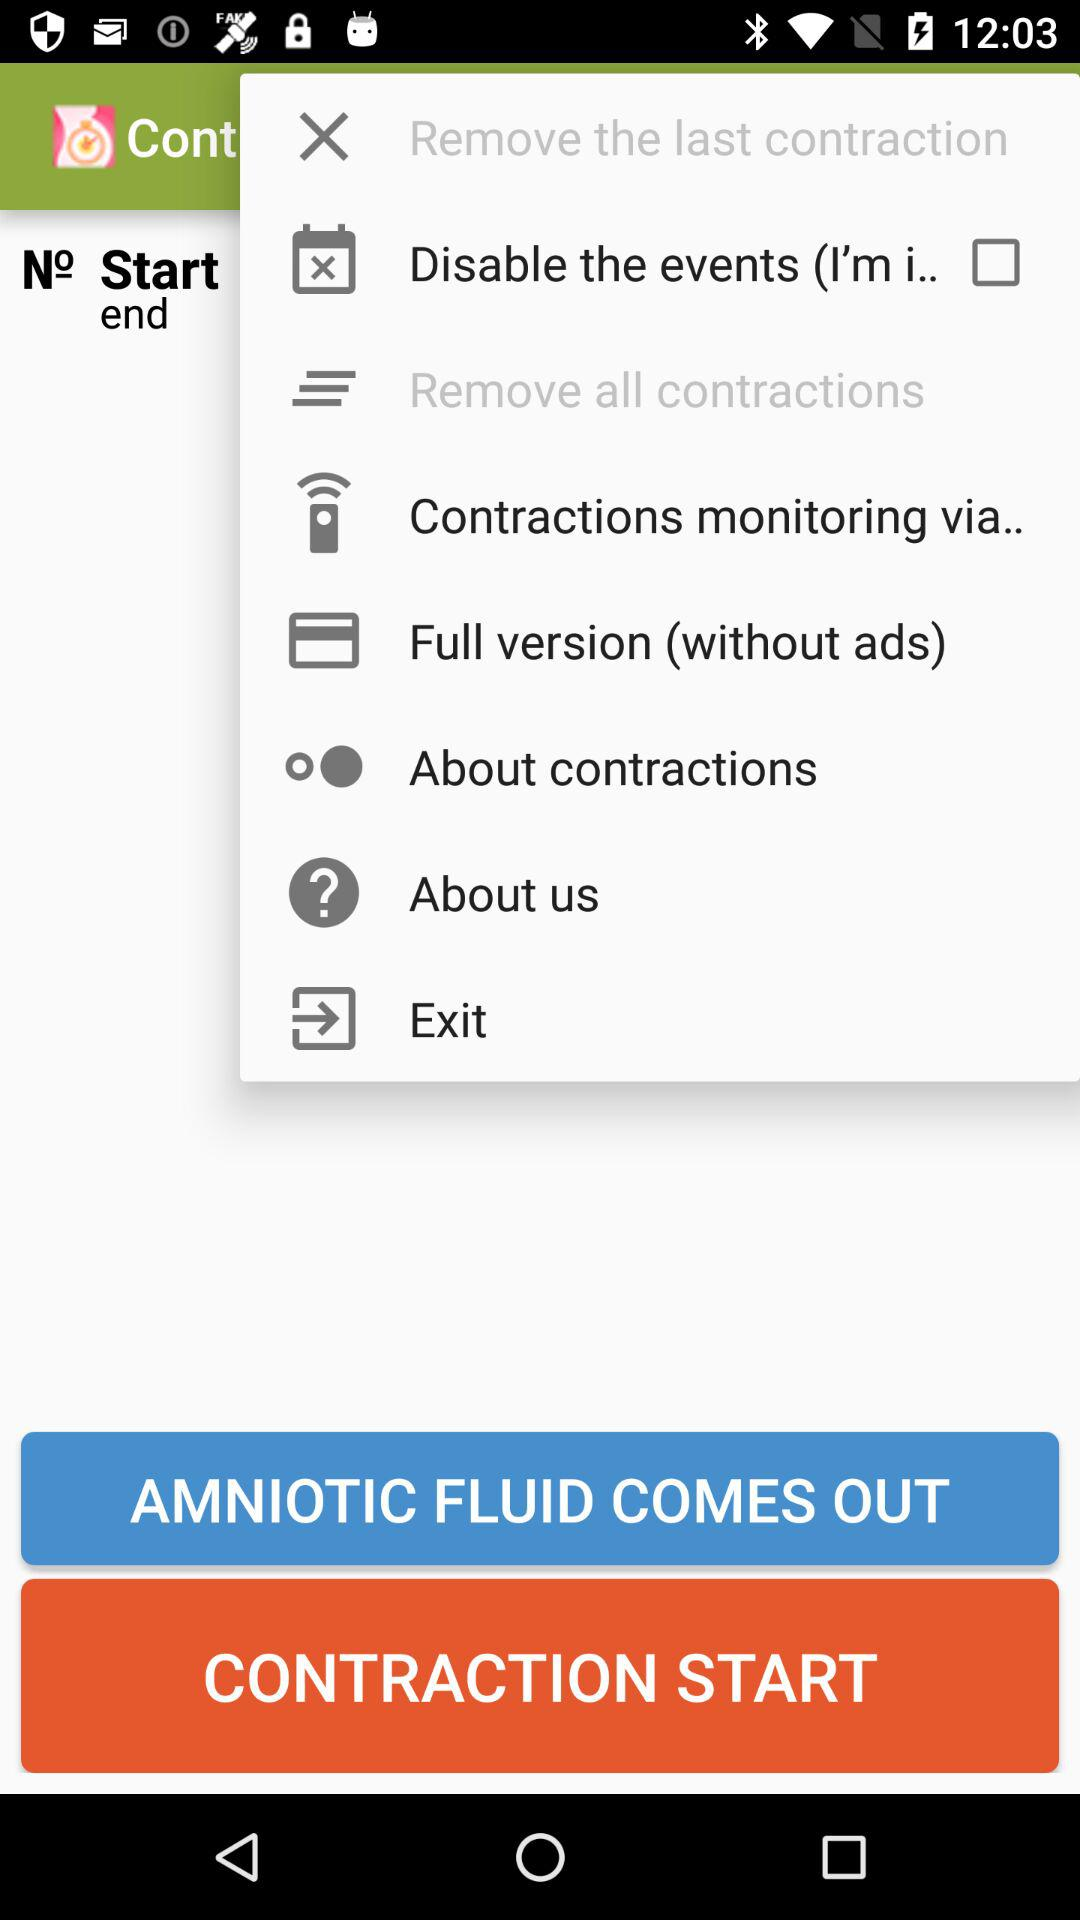What is the status of "Disable the events"? The status is "off". 